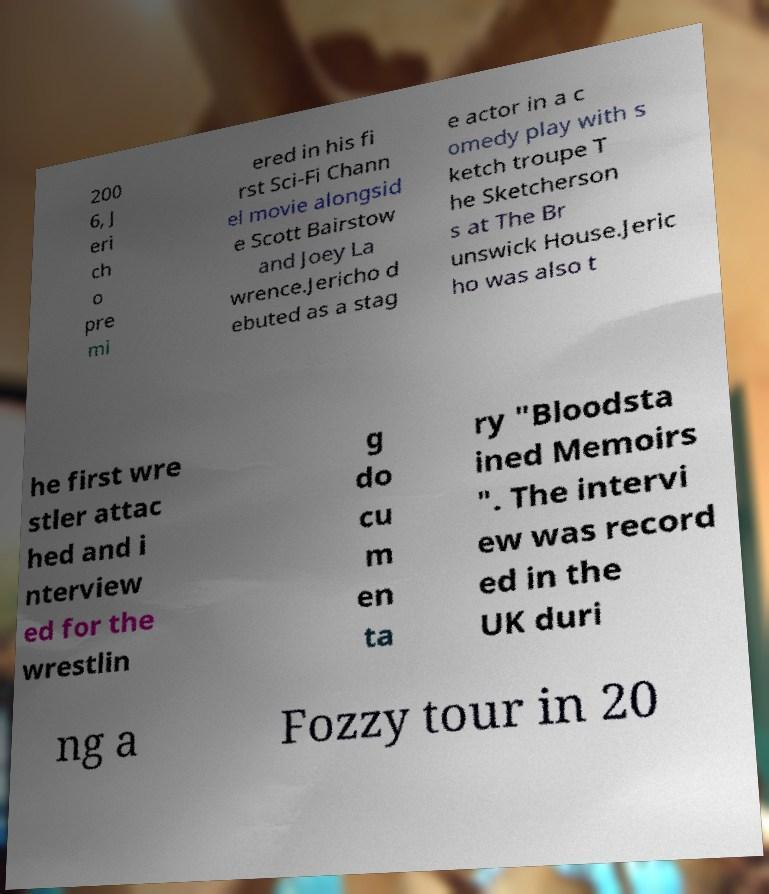Please identify and transcribe the text found in this image. 200 6, J eri ch o pre mi ered in his fi rst Sci-Fi Chann el movie alongsid e Scott Bairstow and Joey La wrence.Jericho d ebuted as a stag e actor in a c omedy play with s ketch troupe T he Sketcherson s at The Br unswick House.Jeric ho was also t he first wre stler attac hed and i nterview ed for the wrestlin g do cu m en ta ry "Bloodsta ined Memoirs ". The intervi ew was record ed in the UK duri ng a Fozzy tour in 20 